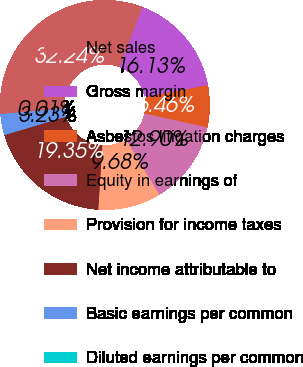Convert chart to OTSL. <chart><loc_0><loc_0><loc_500><loc_500><pie_chart><fcel>Net sales<fcel>Gross margin<fcel>Asbestos litigation charges<fcel>Equity in earnings of<fcel>Provision for income taxes<fcel>Net income attributable to<fcel>Basic earnings per common<fcel>Diluted earnings per common<nl><fcel>32.24%<fcel>16.13%<fcel>6.46%<fcel>12.9%<fcel>9.68%<fcel>19.35%<fcel>3.23%<fcel>0.01%<nl></chart> 